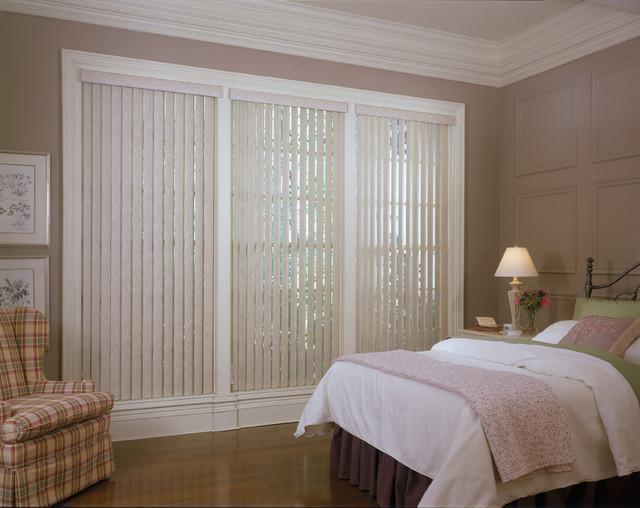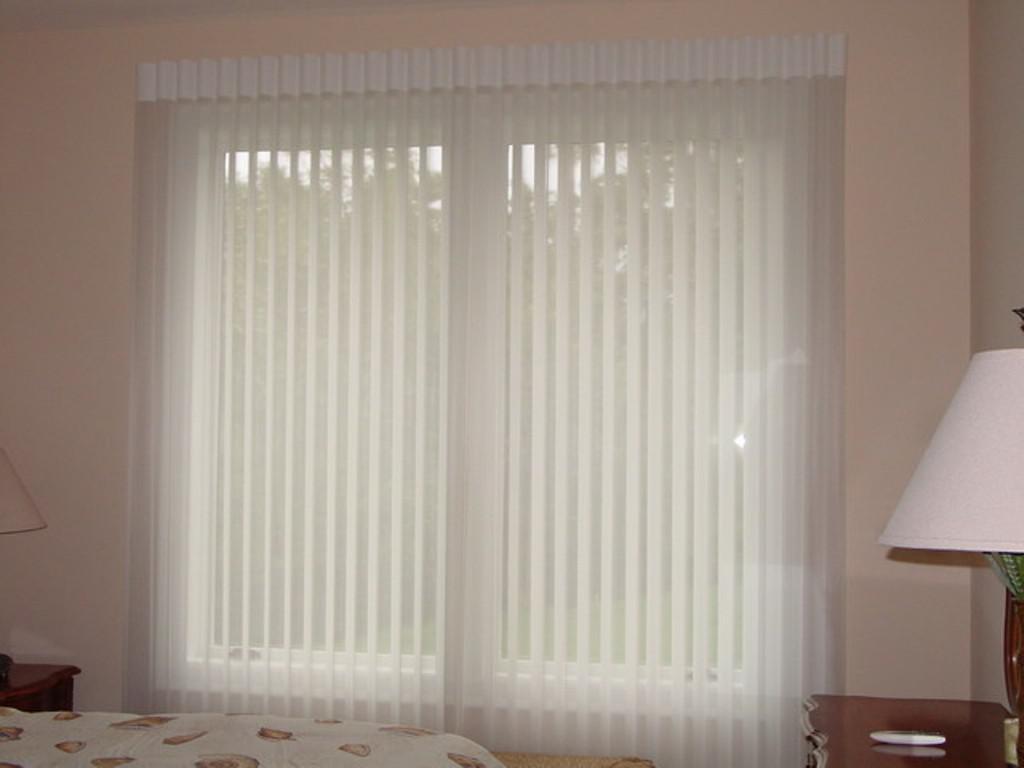The first image is the image on the left, the second image is the image on the right. Examine the images to the left and right. Is the description "There are two beds (any part of a bed) in front of whitish blinds." accurate? Answer yes or no. Yes. 